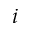<formula> <loc_0><loc_0><loc_500><loc_500>i</formula> 